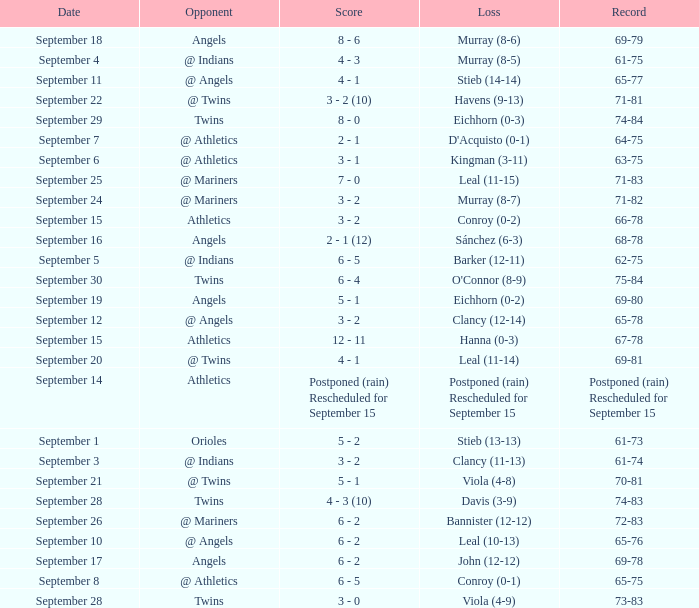Name the score which has record of 73-83 3 - 0. 